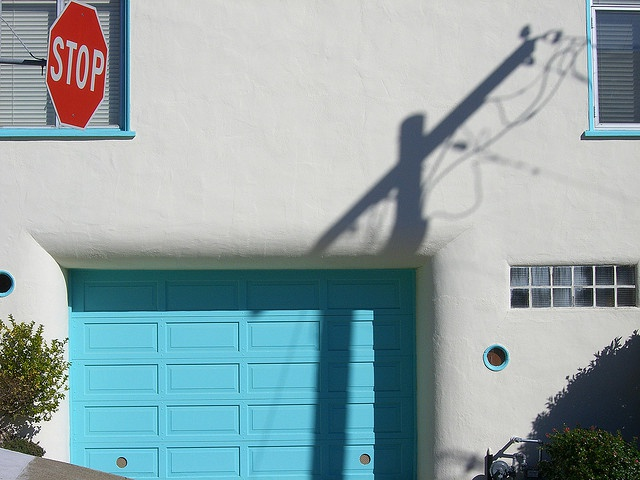Describe the objects in this image and their specific colors. I can see a stop sign in darkgray, brown, and lightgray tones in this image. 